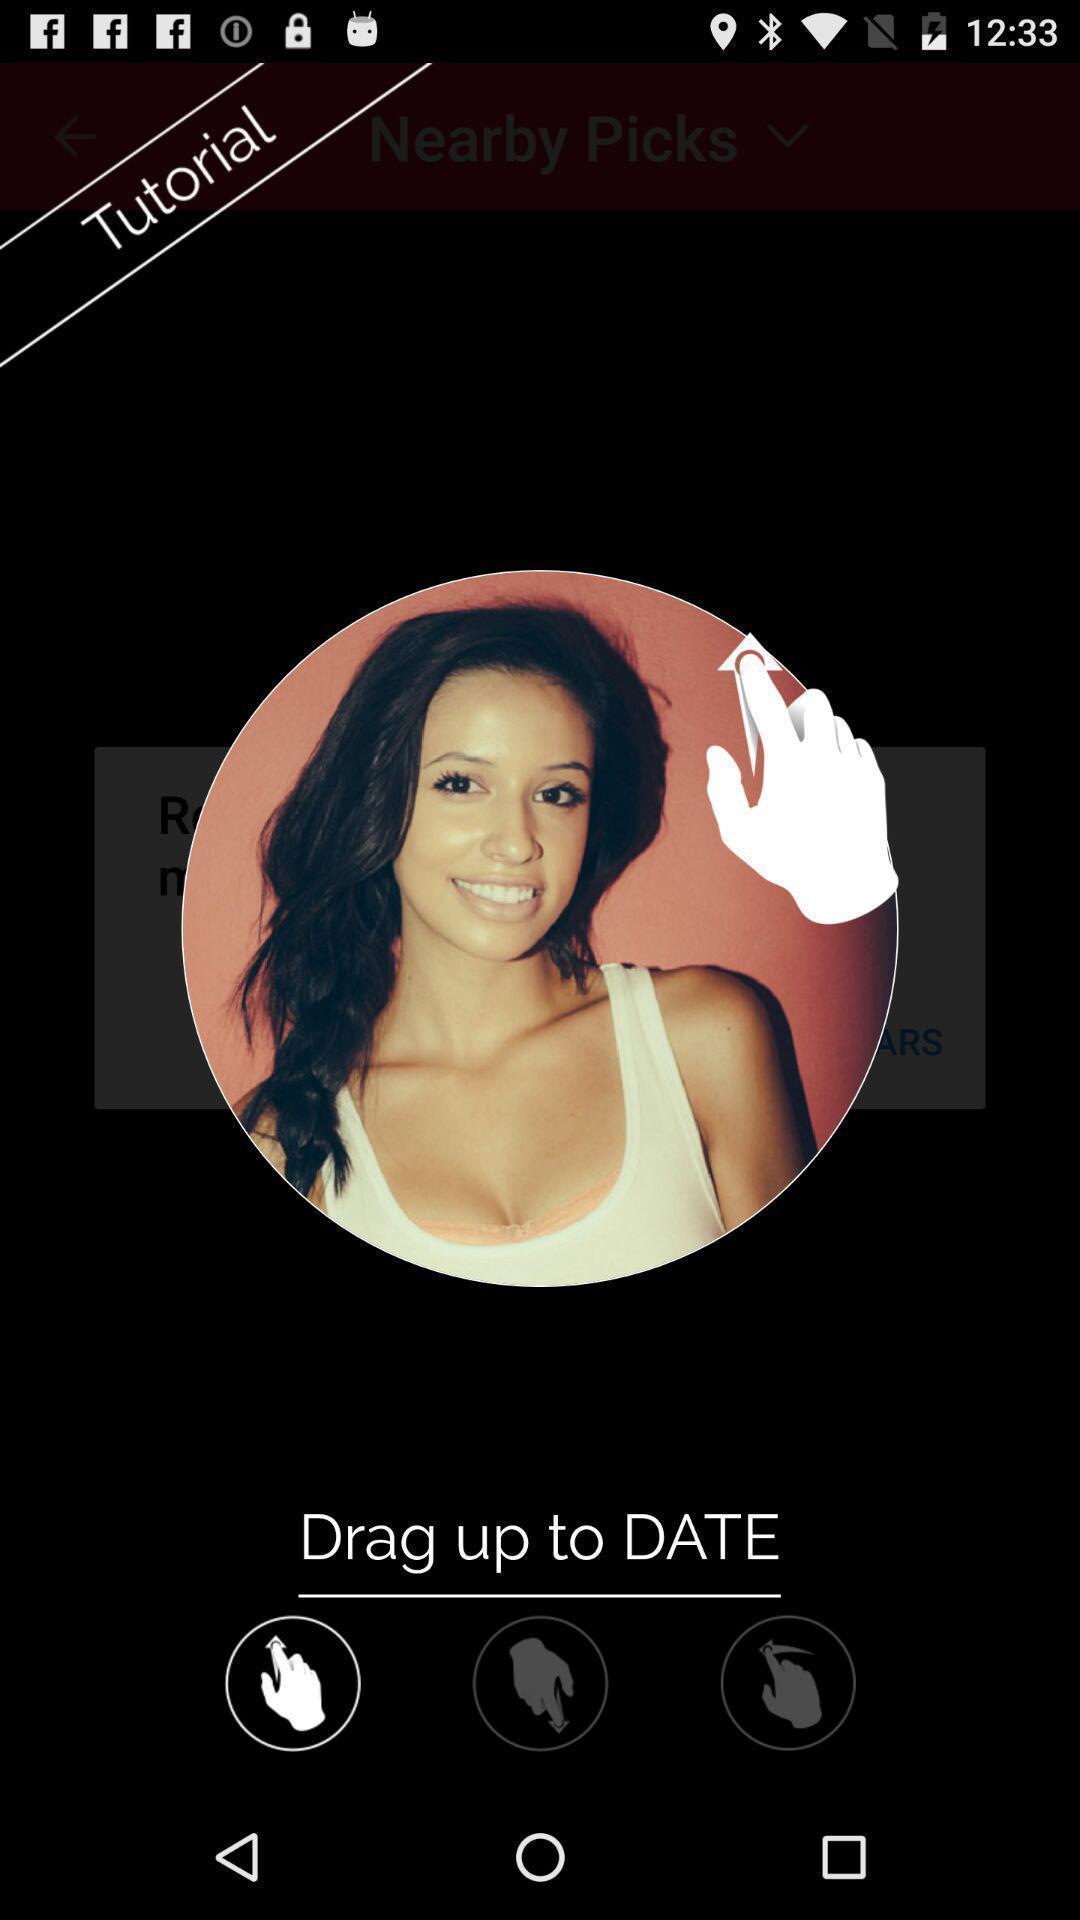Give me a narrative description of this picture. Popup showing a different control option. 